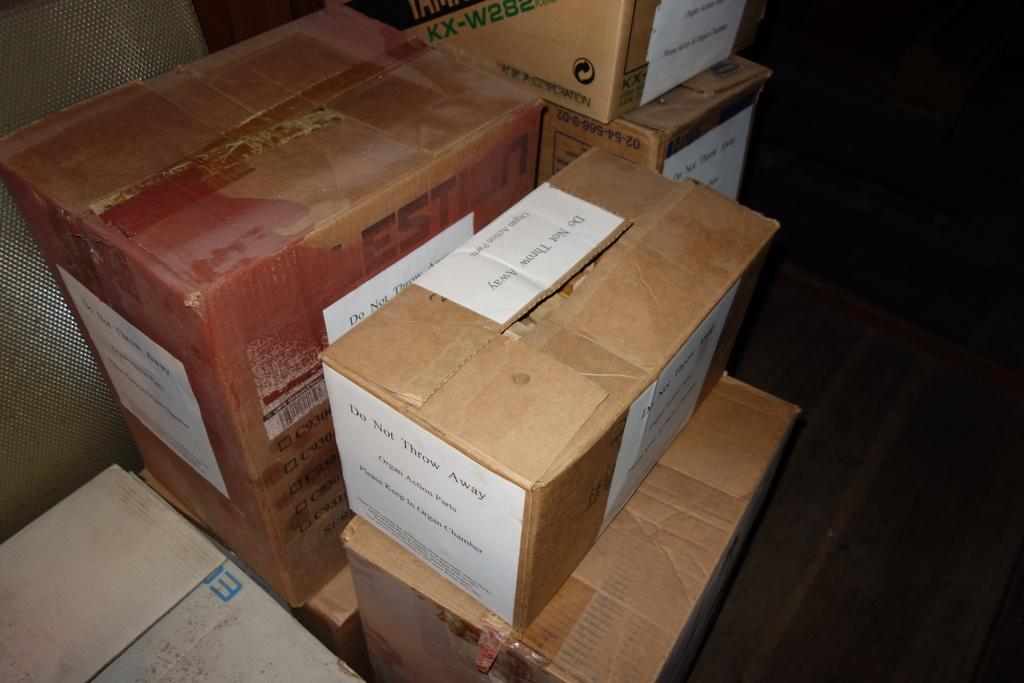Provide a one-sentence caption for the provided image. A box with a note instructing not to throw it away on top is with other boxes. 